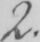What does this handwritten line say? 2 . 